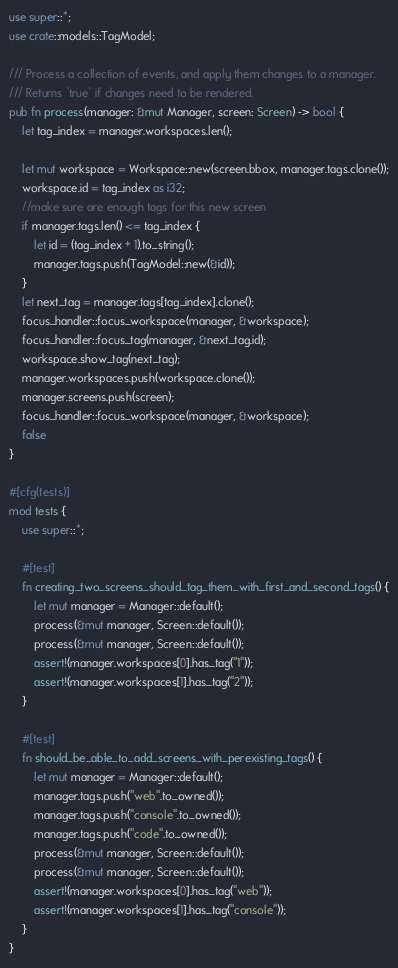<code> <loc_0><loc_0><loc_500><loc_500><_Rust_>use super::*;
use crate::models::TagModel;

/// Process a collection of events, and apply them changes to a manager.
/// Returns `true` if changes need to be rendered.
pub fn process(manager: &mut Manager, screen: Screen) -> bool {
    let tag_index = manager.workspaces.len();

    let mut workspace = Workspace::new(screen.bbox, manager.tags.clone());
    workspace.id = tag_index as i32;
    //make sure are enough tags for this new screen
    if manager.tags.len() <= tag_index {
        let id = (tag_index + 1).to_string();
        manager.tags.push(TagModel::new(&id));
    }
    let next_tag = manager.tags[tag_index].clone();
    focus_handler::focus_workspace(manager, &workspace);
    focus_handler::focus_tag(manager, &next_tag.id);
    workspace.show_tag(next_tag);
    manager.workspaces.push(workspace.clone());
    manager.screens.push(screen);
    focus_handler::focus_workspace(manager, &workspace);
    false
}

#[cfg(tests)]
mod tests {
    use super::*;

    #[test]
    fn creating_two_screens_should_tag_them_with_first_and_second_tags() {
        let mut manager = Manager::default();
        process(&mut manager, Screen::default());
        process(&mut manager, Screen::default());
        assert!(manager.workspaces[0].has_tag("1"));
        assert!(manager.workspaces[1].has_tag("2"));
    }

    #[test]
    fn should_be_able_to_add_screens_with_perexisting_tags() {
        let mut manager = Manager::default();
        manager.tags.push("web".to_owned());
        manager.tags.push("console".to_owned());
        manager.tags.push("code".to_owned());
        process(&mut manager, Screen::default());
        process(&mut manager, Screen::default());
        assert!(manager.workspaces[0].has_tag("web"));
        assert!(manager.workspaces[1].has_tag("console"));
    }
}
</code> 